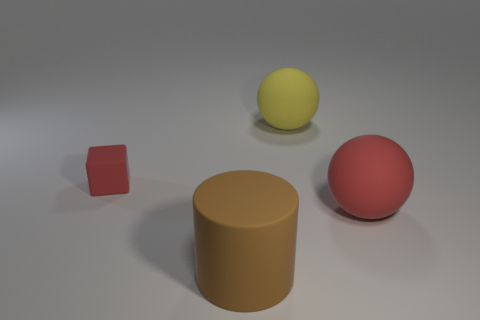What materials appear to be represented by the objects in this image? The objects in the image seem to represent materials such as matte plastic for the small red cube and the large brown cylinder, while the large yellow ball and the red ball on the right appear to have a smooth, perhaps shiny plastic finish. 